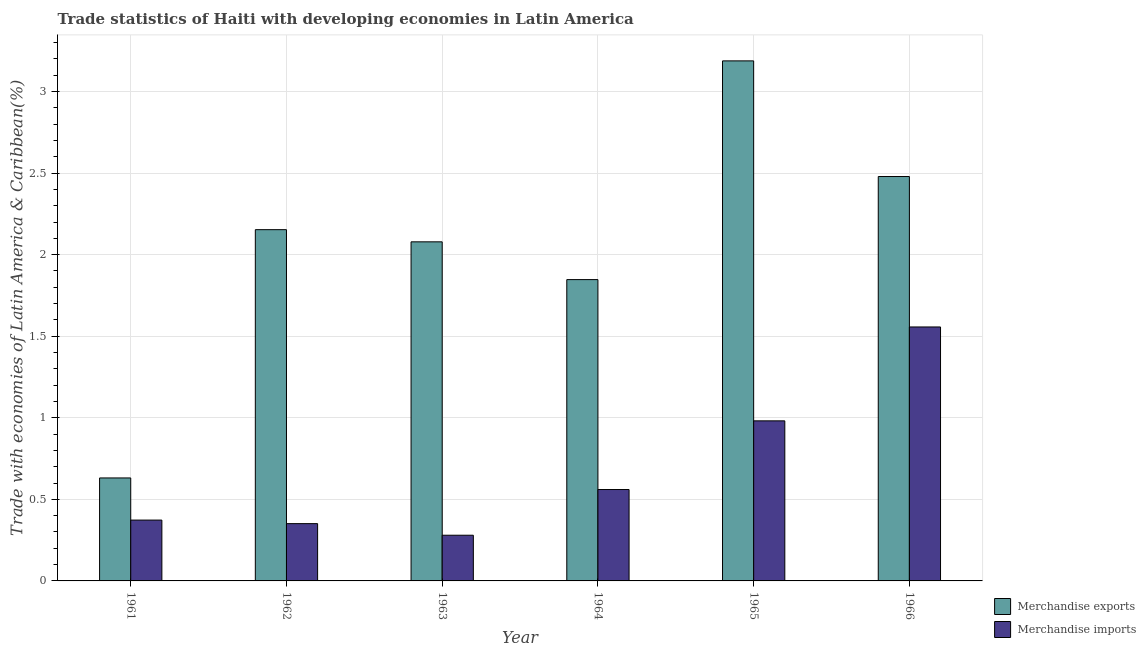How many different coloured bars are there?
Provide a succinct answer. 2. Are the number of bars per tick equal to the number of legend labels?
Provide a succinct answer. Yes. Are the number of bars on each tick of the X-axis equal?
Offer a terse response. Yes. How many bars are there on the 2nd tick from the left?
Give a very brief answer. 2. What is the label of the 4th group of bars from the left?
Your response must be concise. 1964. In how many cases, is the number of bars for a given year not equal to the number of legend labels?
Ensure brevity in your answer.  0. What is the merchandise imports in 1966?
Offer a very short reply. 1.56. Across all years, what is the maximum merchandise imports?
Provide a succinct answer. 1.56. Across all years, what is the minimum merchandise exports?
Your answer should be very brief. 0.63. In which year was the merchandise exports maximum?
Offer a very short reply. 1965. In which year was the merchandise exports minimum?
Provide a succinct answer. 1961. What is the total merchandise exports in the graph?
Give a very brief answer. 12.38. What is the difference between the merchandise imports in 1962 and that in 1966?
Ensure brevity in your answer.  -1.21. What is the difference between the merchandise imports in 1963 and the merchandise exports in 1965?
Your answer should be compact. -0.7. What is the average merchandise exports per year?
Make the answer very short. 2.06. In the year 1964, what is the difference between the merchandise exports and merchandise imports?
Give a very brief answer. 0. In how many years, is the merchandise imports greater than 0.7 %?
Your response must be concise. 2. What is the ratio of the merchandise imports in 1961 to that in 1966?
Your answer should be compact. 0.24. Is the difference between the merchandise imports in 1961 and 1966 greater than the difference between the merchandise exports in 1961 and 1966?
Give a very brief answer. No. What is the difference between the highest and the second highest merchandise exports?
Your answer should be very brief. 0.71. What is the difference between the highest and the lowest merchandise exports?
Provide a short and direct response. 2.56. What does the 1st bar from the left in 1965 represents?
Ensure brevity in your answer.  Merchandise exports. How many bars are there?
Provide a succinct answer. 12. What is the difference between two consecutive major ticks on the Y-axis?
Offer a very short reply. 0.5. Are the values on the major ticks of Y-axis written in scientific E-notation?
Make the answer very short. No. Does the graph contain grids?
Give a very brief answer. Yes. Where does the legend appear in the graph?
Provide a succinct answer. Bottom right. What is the title of the graph?
Give a very brief answer. Trade statistics of Haiti with developing economies in Latin America. Does "Girls" appear as one of the legend labels in the graph?
Keep it short and to the point. No. What is the label or title of the Y-axis?
Your answer should be very brief. Trade with economies of Latin America & Caribbean(%). What is the Trade with economies of Latin America & Caribbean(%) of Merchandise exports in 1961?
Provide a succinct answer. 0.63. What is the Trade with economies of Latin America & Caribbean(%) of Merchandise imports in 1961?
Provide a short and direct response. 0.37. What is the Trade with economies of Latin America & Caribbean(%) in Merchandise exports in 1962?
Provide a short and direct response. 2.15. What is the Trade with economies of Latin America & Caribbean(%) in Merchandise imports in 1962?
Ensure brevity in your answer.  0.35. What is the Trade with economies of Latin America & Caribbean(%) in Merchandise exports in 1963?
Make the answer very short. 2.08. What is the Trade with economies of Latin America & Caribbean(%) in Merchandise imports in 1963?
Ensure brevity in your answer.  0.28. What is the Trade with economies of Latin America & Caribbean(%) of Merchandise exports in 1964?
Your response must be concise. 1.85. What is the Trade with economies of Latin America & Caribbean(%) of Merchandise imports in 1964?
Offer a terse response. 0.56. What is the Trade with economies of Latin America & Caribbean(%) in Merchandise exports in 1965?
Ensure brevity in your answer.  3.19. What is the Trade with economies of Latin America & Caribbean(%) in Merchandise imports in 1965?
Provide a succinct answer. 0.98. What is the Trade with economies of Latin America & Caribbean(%) of Merchandise exports in 1966?
Keep it short and to the point. 2.48. What is the Trade with economies of Latin America & Caribbean(%) of Merchandise imports in 1966?
Offer a terse response. 1.56. Across all years, what is the maximum Trade with economies of Latin America & Caribbean(%) in Merchandise exports?
Provide a succinct answer. 3.19. Across all years, what is the maximum Trade with economies of Latin America & Caribbean(%) in Merchandise imports?
Your answer should be compact. 1.56. Across all years, what is the minimum Trade with economies of Latin America & Caribbean(%) in Merchandise exports?
Make the answer very short. 0.63. Across all years, what is the minimum Trade with economies of Latin America & Caribbean(%) in Merchandise imports?
Your response must be concise. 0.28. What is the total Trade with economies of Latin America & Caribbean(%) in Merchandise exports in the graph?
Ensure brevity in your answer.  12.38. What is the total Trade with economies of Latin America & Caribbean(%) of Merchandise imports in the graph?
Make the answer very short. 4.1. What is the difference between the Trade with economies of Latin America & Caribbean(%) in Merchandise exports in 1961 and that in 1962?
Your answer should be very brief. -1.52. What is the difference between the Trade with economies of Latin America & Caribbean(%) in Merchandise imports in 1961 and that in 1962?
Your answer should be compact. 0.02. What is the difference between the Trade with economies of Latin America & Caribbean(%) in Merchandise exports in 1961 and that in 1963?
Offer a terse response. -1.45. What is the difference between the Trade with economies of Latin America & Caribbean(%) in Merchandise imports in 1961 and that in 1963?
Provide a succinct answer. 0.09. What is the difference between the Trade with economies of Latin America & Caribbean(%) of Merchandise exports in 1961 and that in 1964?
Your answer should be compact. -1.22. What is the difference between the Trade with economies of Latin America & Caribbean(%) of Merchandise imports in 1961 and that in 1964?
Your answer should be compact. -0.19. What is the difference between the Trade with economies of Latin America & Caribbean(%) of Merchandise exports in 1961 and that in 1965?
Keep it short and to the point. -2.56. What is the difference between the Trade with economies of Latin America & Caribbean(%) in Merchandise imports in 1961 and that in 1965?
Keep it short and to the point. -0.61. What is the difference between the Trade with economies of Latin America & Caribbean(%) of Merchandise exports in 1961 and that in 1966?
Keep it short and to the point. -1.85. What is the difference between the Trade with economies of Latin America & Caribbean(%) of Merchandise imports in 1961 and that in 1966?
Keep it short and to the point. -1.18. What is the difference between the Trade with economies of Latin America & Caribbean(%) of Merchandise exports in 1962 and that in 1963?
Provide a short and direct response. 0.07. What is the difference between the Trade with economies of Latin America & Caribbean(%) in Merchandise imports in 1962 and that in 1963?
Your answer should be very brief. 0.07. What is the difference between the Trade with economies of Latin America & Caribbean(%) of Merchandise exports in 1962 and that in 1964?
Ensure brevity in your answer.  0.31. What is the difference between the Trade with economies of Latin America & Caribbean(%) in Merchandise imports in 1962 and that in 1964?
Your response must be concise. -0.21. What is the difference between the Trade with economies of Latin America & Caribbean(%) of Merchandise exports in 1962 and that in 1965?
Keep it short and to the point. -1.03. What is the difference between the Trade with economies of Latin America & Caribbean(%) of Merchandise imports in 1962 and that in 1965?
Make the answer very short. -0.63. What is the difference between the Trade with economies of Latin America & Caribbean(%) of Merchandise exports in 1962 and that in 1966?
Your answer should be very brief. -0.33. What is the difference between the Trade with economies of Latin America & Caribbean(%) in Merchandise imports in 1962 and that in 1966?
Provide a succinct answer. -1.21. What is the difference between the Trade with economies of Latin America & Caribbean(%) of Merchandise exports in 1963 and that in 1964?
Give a very brief answer. 0.23. What is the difference between the Trade with economies of Latin America & Caribbean(%) in Merchandise imports in 1963 and that in 1964?
Keep it short and to the point. -0.28. What is the difference between the Trade with economies of Latin America & Caribbean(%) of Merchandise exports in 1963 and that in 1965?
Provide a short and direct response. -1.11. What is the difference between the Trade with economies of Latin America & Caribbean(%) in Merchandise imports in 1963 and that in 1965?
Give a very brief answer. -0.7. What is the difference between the Trade with economies of Latin America & Caribbean(%) in Merchandise exports in 1963 and that in 1966?
Give a very brief answer. -0.4. What is the difference between the Trade with economies of Latin America & Caribbean(%) of Merchandise imports in 1963 and that in 1966?
Ensure brevity in your answer.  -1.28. What is the difference between the Trade with economies of Latin America & Caribbean(%) in Merchandise exports in 1964 and that in 1965?
Your answer should be compact. -1.34. What is the difference between the Trade with economies of Latin America & Caribbean(%) of Merchandise imports in 1964 and that in 1965?
Your response must be concise. -0.42. What is the difference between the Trade with economies of Latin America & Caribbean(%) of Merchandise exports in 1964 and that in 1966?
Your answer should be compact. -0.63. What is the difference between the Trade with economies of Latin America & Caribbean(%) of Merchandise imports in 1964 and that in 1966?
Ensure brevity in your answer.  -1. What is the difference between the Trade with economies of Latin America & Caribbean(%) of Merchandise exports in 1965 and that in 1966?
Offer a very short reply. 0.71. What is the difference between the Trade with economies of Latin America & Caribbean(%) of Merchandise imports in 1965 and that in 1966?
Your answer should be compact. -0.58. What is the difference between the Trade with economies of Latin America & Caribbean(%) of Merchandise exports in 1961 and the Trade with economies of Latin America & Caribbean(%) of Merchandise imports in 1962?
Provide a short and direct response. 0.28. What is the difference between the Trade with economies of Latin America & Caribbean(%) in Merchandise exports in 1961 and the Trade with economies of Latin America & Caribbean(%) in Merchandise imports in 1963?
Make the answer very short. 0.35. What is the difference between the Trade with economies of Latin America & Caribbean(%) of Merchandise exports in 1961 and the Trade with economies of Latin America & Caribbean(%) of Merchandise imports in 1964?
Your answer should be very brief. 0.07. What is the difference between the Trade with economies of Latin America & Caribbean(%) of Merchandise exports in 1961 and the Trade with economies of Latin America & Caribbean(%) of Merchandise imports in 1965?
Offer a terse response. -0.35. What is the difference between the Trade with economies of Latin America & Caribbean(%) of Merchandise exports in 1961 and the Trade with economies of Latin America & Caribbean(%) of Merchandise imports in 1966?
Keep it short and to the point. -0.93. What is the difference between the Trade with economies of Latin America & Caribbean(%) of Merchandise exports in 1962 and the Trade with economies of Latin America & Caribbean(%) of Merchandise imports in 1963?
Provide a short and direct response. 1.87. What is the difference between the Trade with economies of Latin America & Caribbean(%) of Merchandise exports in 1962 and the Trade with economies of Latin America & Caribbean(%) of Merchandise imports in 1964?
Keep it short and to the point. 1.59. What is the difference between the Trade with economies of Latin America & Caribbean(%) in Merchandise exports in 1962 and the Trade with economies of Latin America & Caribbean(%) in Merchandise imports in 1965?
Your answer should be compact. 1.17. What is the difference between the Trade with economies of Latin America & Caribbean(%) in Merchandise exports in 1962 and the Trade with economies of Latin America & Caribbean(%) in Merchandise imports in 1966?
Your answer should be compact. 0.6. What is the difference between the Trade with economies of Latin America & Caribbean(%) of Merchandise exports in 1963 and the Trade with economies of Latin America & Caribbean(%) of Merchandise imports in 1964?
Provide a succinct answer. 1.52. What is the difference between the Trade with economies of Latin America & Caribbean(%) in Merchandise exports in 1963 and the Trade with economies of Latin America & Caribbean(%) in Merchandise imports in 1965?
Your answer should be compact. 1.1. What is the difference between the Trade with economies of Latin America & Caribbean(%) in Merchandise exports in 1963 and the Trade with economies of Latin America & Caribbean(%) in Merchandise imports in 1966?
Your response must be concise. 0.52. What is the difference between the Trade with economies of Latin America & Caribbean(%) in Merchandise exports in 1964 and the Trade with economies of Latin America & Caribbean(%) in Merchandise imports in 1965?
Offer a terse response. 0.87. What is the difference between the Trade with economies of Latin America & Caribbean(%) of Merchandise exports in 1964 and the Trade with economies of Latin America & Caribbean(%) of Merchandise imports in 1966?
Make the answer very short. 0.29. What is the difference between the Trade with economies of Latin America & Caribbean(%) of Merchandise exports in 1965 and the Trade with economies of Latin America & Caribbean(%) of Merchandise imports in 1966?
Offer a terse response. 1.63. What is the average Trade with economies of Latin America & Caribbean(%) in Merchandise exports per year?
Provide a short and direct response. 2.06. What is the average Trade with economies of Latin America & Caribbean(%) of Merchandise imports per year?
Your answer should be very brief. 0.68. In the year 1961, what is the difference between the Trade with economies of Latin America & Caribbean(%) in Merchandise exports and Trade with economies of Latin America & Caribbean(%) in Merchandise imports?
Your answer should be very brief. 0.26. In the year 1962, what is the difference between the Trade with economies of Latin America & Caribbean(%) in Merchandise exports and Trade with economies of Latin America & Caribbean(%) in Merchandise imports?
Give a very brief answer. 1.8. In the year 1963, what is the difference between the Trade with economies of Latin America & Caribbean(%) in Merchandise exports and Trade with economies of Latin America & Caribbean(%) in Merchandise imports?
Your response must be concise. 1.8. In the year 1964, what is the difference between the Trade with economies of Latin America & Caribbean(%) of Merchandise exports and Trade with economies of Latin America & Caribbean(%) of Merchandise imports?
Make the answer very short. 1.29. In the year 1965, what is the difference between the Trade with economies of Latin America & Caribbean(%) in Merchandise exports and Trade with economies of Latin America & Caribbean(%) in Merchandise imports?
Offer a very short reply. 2.21. In the year 1966, what is the difference between the Trade with economies of Latin America & Caribbean(%) in Merchandise exports and Trade with economies of Latin America & Caribbean(%) in Merchandise imports?
Offer a terse response. 0.92. What is the ratio of the Trade with economies of Latin America & Caribbean(%) of Merchandise exports in 1961 to that in 1962?
Your answer should be compact. 0.29. What is the ratio of the Trade with economies of Latin America & Caribbean(%) in Merchandise imports in 1961 to that in 1962?
Your answer should be very brief. 1.06. What is the ratio of the Trade with economies of Latin America & Caribbean(%) of Merchandise exports in 1961 to that in 1963?
Provide a short and direct response. 0.3. What is the ratio of the Trade with economies of Latin America & Caribbean(%) of Merchandise imports in 1961 to that in 1963?
Give a very brief answer. 1.33. What is the ratio of the Trade with economies of Latin America & Caribbean(%) in Merchandise exports in 1961 to that in 1964?
Provide a succinct answer. 0.34. What is the ratio of the Trade with economies of Latin America & Caribbean(%) of Merchandise imports in 1961 to that in 1964?
Your response must be concise. 0.67. What is the ratio of the Trade with economies of Latin America & Caribbean(%) of Merchandise exports in 1961 to that in 1965?
Offer a very short reply. 0.2. What is the ratio of the Trade with economies of Latin America & Caribbean(%) of Merchandise imports in 1961 to that in 1965?
Keep it short and to the point. 0.38. What is the ratio of the Trade with economies of Latin America & Caribbean(%) in Merchandise exports in 1961 to that in 1966?
Your response must be concise. 0.25. What is the ratio of the Trade with economies of Latin America & Caribbean(%) of Merchandise imports in 1961 to that in 1966?
Your answer should be very brief. 0.24. What is the ratio of the Trade with economies of Latin America & Caribbean(%) of Merchandise exports in 1962 to that in 1963?
Your answer should be compact. 1.04. What is the ratio of the Trade with economies of Latin America & Caribbean(%) in Merchandise imports in 1962 to that in 1963?
Your answer should be compact. 1.25. What is the ratio of the Trade with economies of Latin America & Caribbean(%) in Merchandise exports in 1962 to that in 1964?
Keep it short and to the point. 1.17. What is the ratio of the Trade with economies of Latin America & Caribbean(%) of Merchandise imports in 1962 to that in 1964?
Provide a short and direct response. 0.63. What is the ratio of the Trade with economies of Latin America & Caribbean(%) in Merchandise exports in 1962 to that in 1965?
Keep it short and to the point. 0.68. What is the ratio of the Trade with economies of Latin America & Caribbean(%) of Merchandise imports in 1962 to that in 1965?
Give a very brief answer. 0.36. What is the ratio of the Trade with economies of Latin America & Caribbean(%) of Merchandise exports in 1962 to that in 1966?
Keep it short and to the point. 0.87. What is the ratio of the Trade with economies of Latin America & Caribbean(%) of Merchandise imports in 1962 to that in 1966?
Ensure brevity in your answer.  0.23. What is the ratio of the Trade with economies of Latin America & Caribbean(%) of Merchandise exports in 1963 to that in 1964?
Make the answer very short. 1.13. What is the ratio of the Trade with economies of Latin America & Caribbean(%) of Merchandise exports in 1963 to that in 1965?
Make the answer very short. 0.65. What is the ratio of the Trade with economies of Latin America & Caribbean(%) in Merchandise imports in 1963 to that in 1965?
Your answer should be compact. 0.29. What is the ratio of the Trade with economies of Latin America & Caribbean(%) of Merchandise exports in 1963 to that in 1966?
Ensure brevity in your answer.  0.84. What is the ratio of the Trade with economies of Latin America & Caribbean(%) of Merchandise imports in 1963 to that in 1966?
Provide a succinct answer. 0.18. What is the ratio of the Trade with economies of Latin America & Caribbean(%) of Merchandise exports in 1964 to that in 1965?
Offer a terse response. 0.58. What is the ratio of the Trade with economies of Latin America & Caribbean(%) in Merchandise imports in 1964 to that in 1965?
Provide a succinct answer. 0.57. What is the ratio of the Trade with economies of Latin America & Caribbean(%) in Merchandise exports in 1964 to that in 1966?
Keep it short and to the point. 0.75. What is the ratio of the Trade with economies of Latin America & Caribbean(%) in Merchandise imports in 1964 to that in 1966?
Keep it short and to the point. 0.36. What is the ratio of the Trade with economies of Latin America & Caribbean(%) in Merchandise exports in 1965 to that in 1966?
Provide a succinct answer. 1.29. What is the ratio of the Trade with economies of Latin America & Caribbean(%) of Merchandise imports in 1965 to that in 1966?
Your answer should be compact. 0.63. What is the difference between the highest and the second highest Trade with economies of Latin America & Caribbean(%) in Merchandise exports?
Keep it short and to the point. 0.71. What is the difference between the highest and the second highest Trade with economies of Latin America & Caribbean(%) of Merchandise imports?
Give a very brief answer. 0.58. What is the difference between the highest and the lowest Trade with economies of Latin America & Caribbean(%) in Merchandise exports?
Offer a very short reply. 2.56. What is the difference between the highest and the lowest Trade with economies of Latin America & Caribbean(%) in Merchandise imports?
Provide a short and direct response. 1.28. 